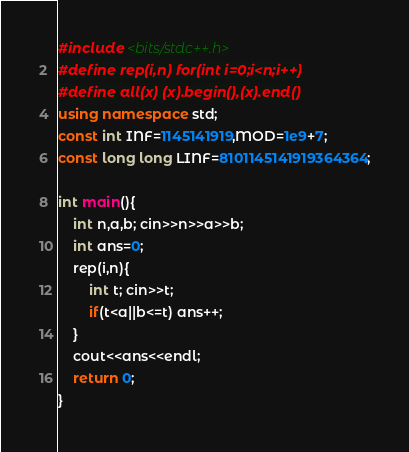Convert code to text. <code><loc_0><loc_0><loc_500><loc_500><_C++_>#include <bits/stdc++.h>
#define rep(i,n) for(int i=0;i<n;i++)
#define all(x) (x).begin(),(x).end()
using namespace std;
const int INF=1145141919,MOD=1e9+7;
const long long LINF=8101145141919364364;

int main(){
	int n,a,b; cin>>n>>a>>b;
	int ans=0;
	rep(i,n){
		int t; cin>>t;
		if(t<a||b<=t) ans++;
	}
	cout<<ans<<endl;
	return 0;
}
</code> 